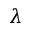<formula> <loc_0><loc_0><loc_500><loc_500>\lambda</formula> 